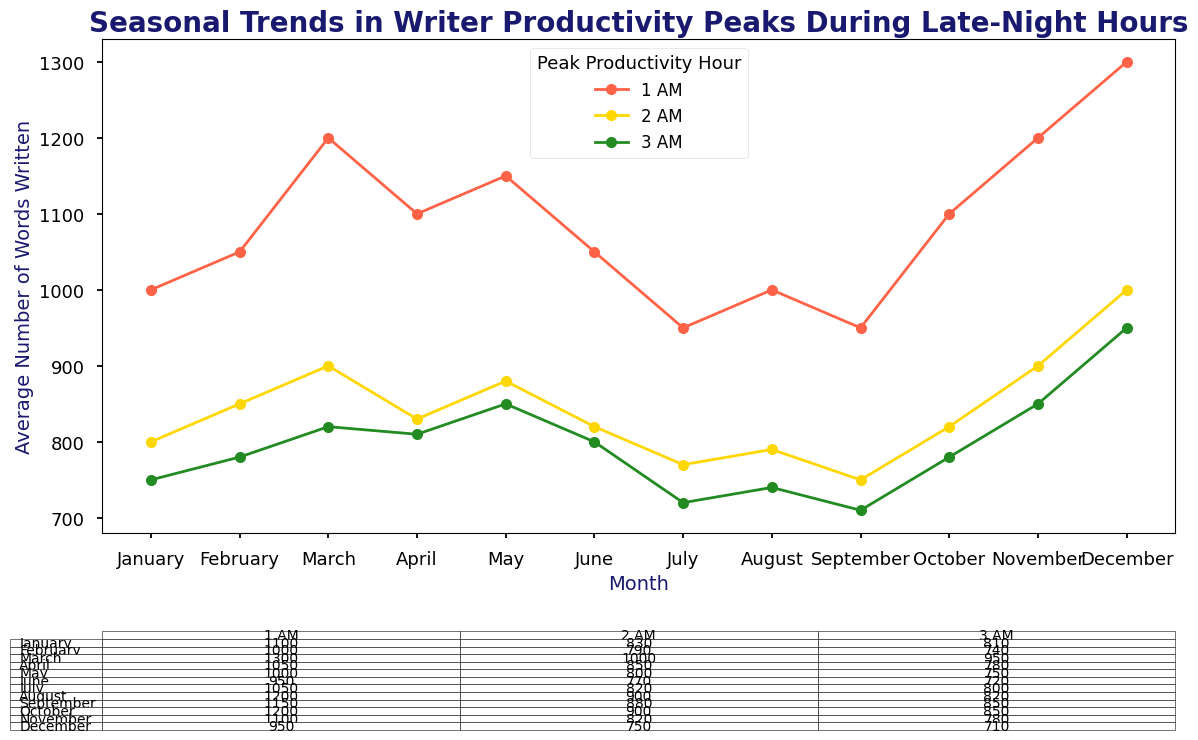What is the peak productivity hour with the highest average number of words written in December? Refer to the table for December and find the hour with the highest value. In December, the average numbers of words written are 1300 at 1 AM, 1000 at 2 AM, and 950 at 3 AM. 1 AM has the highest value.
Answer: 1 AM Which month shows the largest decrease in average number of words written between 1 AM and 2 AM? Calculate the difference for each month and find the one with the largest difference. For January: 1000 - 800 = 200, February: 1050 - 850 = 200, … December: 1300 - 1000 = 300. December has the largest decrease of 300.
Answer: December What is the average number of words written at 2 AM across all months? Sum the average number of words for 2 AM across all months and then divide by the number of months. Here, (800 + 850 + 900 + 830 + 880 + 820 + 770 + 790 + 750 + 820 + 900 + 1000) / 12 = 9100 / 12 = 758.33.
Answer: 758.33 Between which two consecutive months does the average number of words written at 3 AM increase the most? Calculate the differences between consecutive months for 3 AM and find the largest. For January to February: 780 - 750 = 30, March: 820 - 780 = 40, … August to September: 710 - 740 = -30, October to November: 850 - 780 = 70. Thus, the largest increase of 70 occurs from October to November.
Answer: October to November During which hour is the productivity the most consistent across the months in terms of average number of words written? Calculate the standard deviation for each hour’s average words and find the hour with the smallest standard deviation. For 1 AM: std_dev = Stdev([1000, 1050, 1200, 1100, 1150, 1050, 950, 1000, 950, 1100, 1200, 1300]), 2 AM, and 3 AM similarly. The smallest std_dev indicates most consistency. 3 AM has the smallest std_dev.
Answer: 3 AM Which month has the highest overall average number of words written across all hours? Calculate the average number of words written for each month across all hours. January: (1000 + 800 + 750) / 3 = 850, … December: (1300 + 1000 + 950) / 3 = 1083.33. December has the highest overall average.
Answer: December 